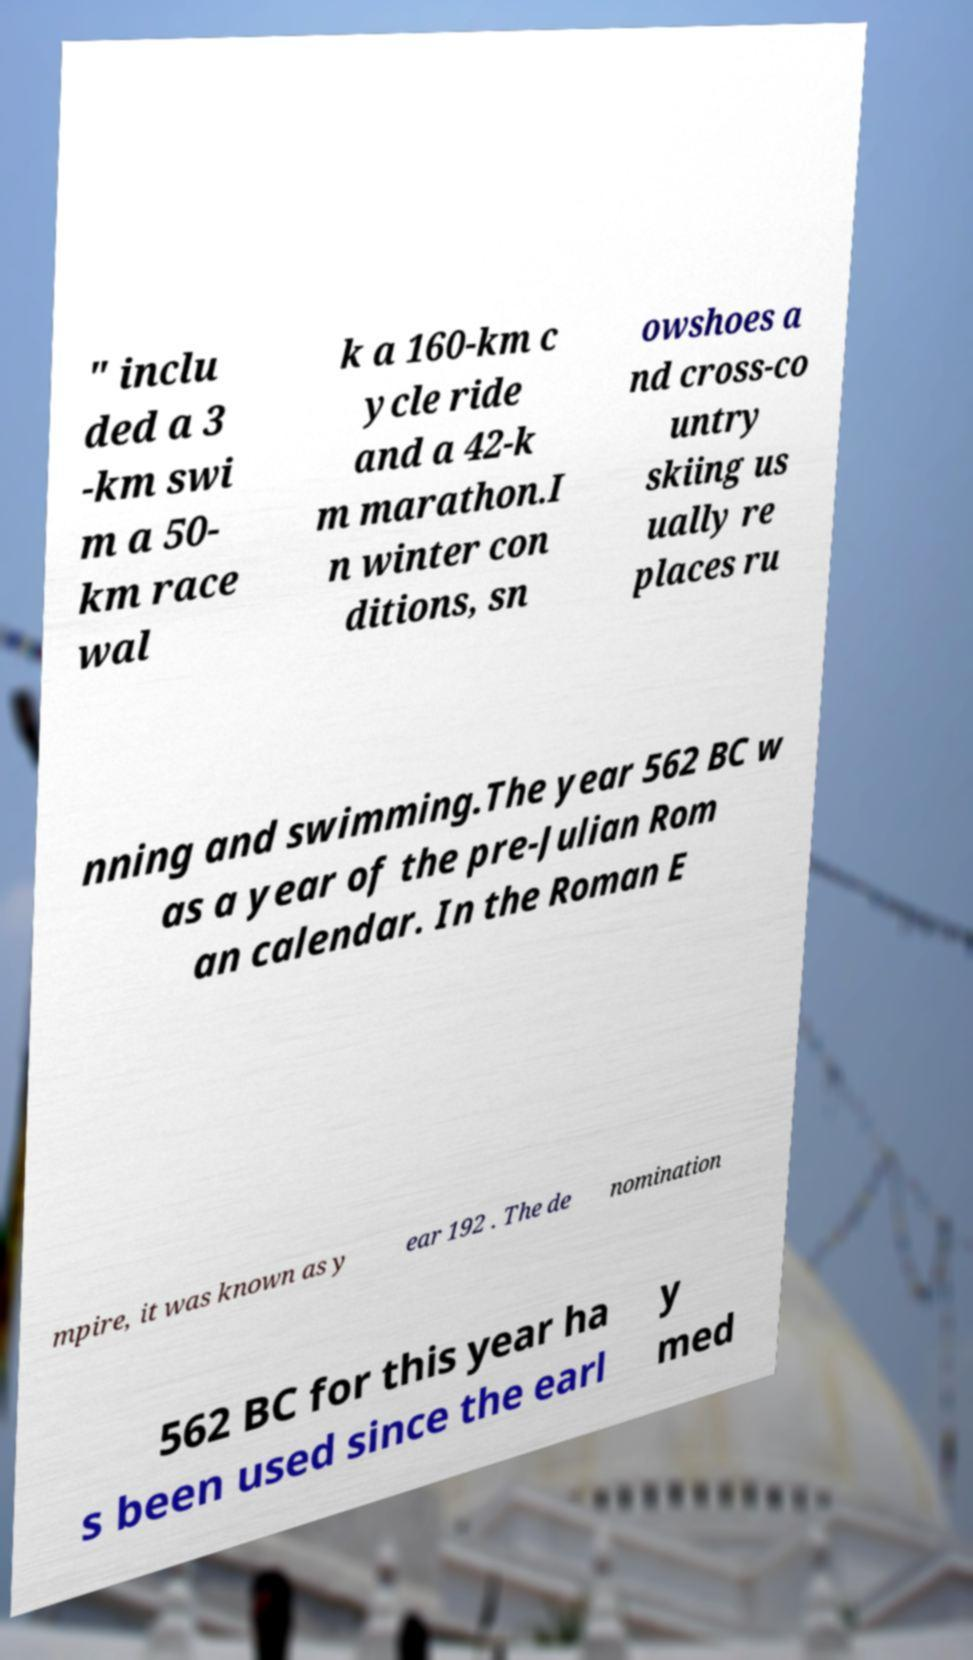Please read and relay the text visible in this image. What does it say? " inclu ded a 3 -km swi m a 50- km race wal k a 160-km c ycle ride and a 42-k m marathon.I n winter con ditions, sn owshoes a nd cross-co untry skiing us ually re places ru nning and swimming.The year 562 BC w as a year of the pre-Julian Rom an calendar. In the Roman E mpire, it was known as y ear 192 . The de nomination 562 BC for this year ha s been used since the earl y med 